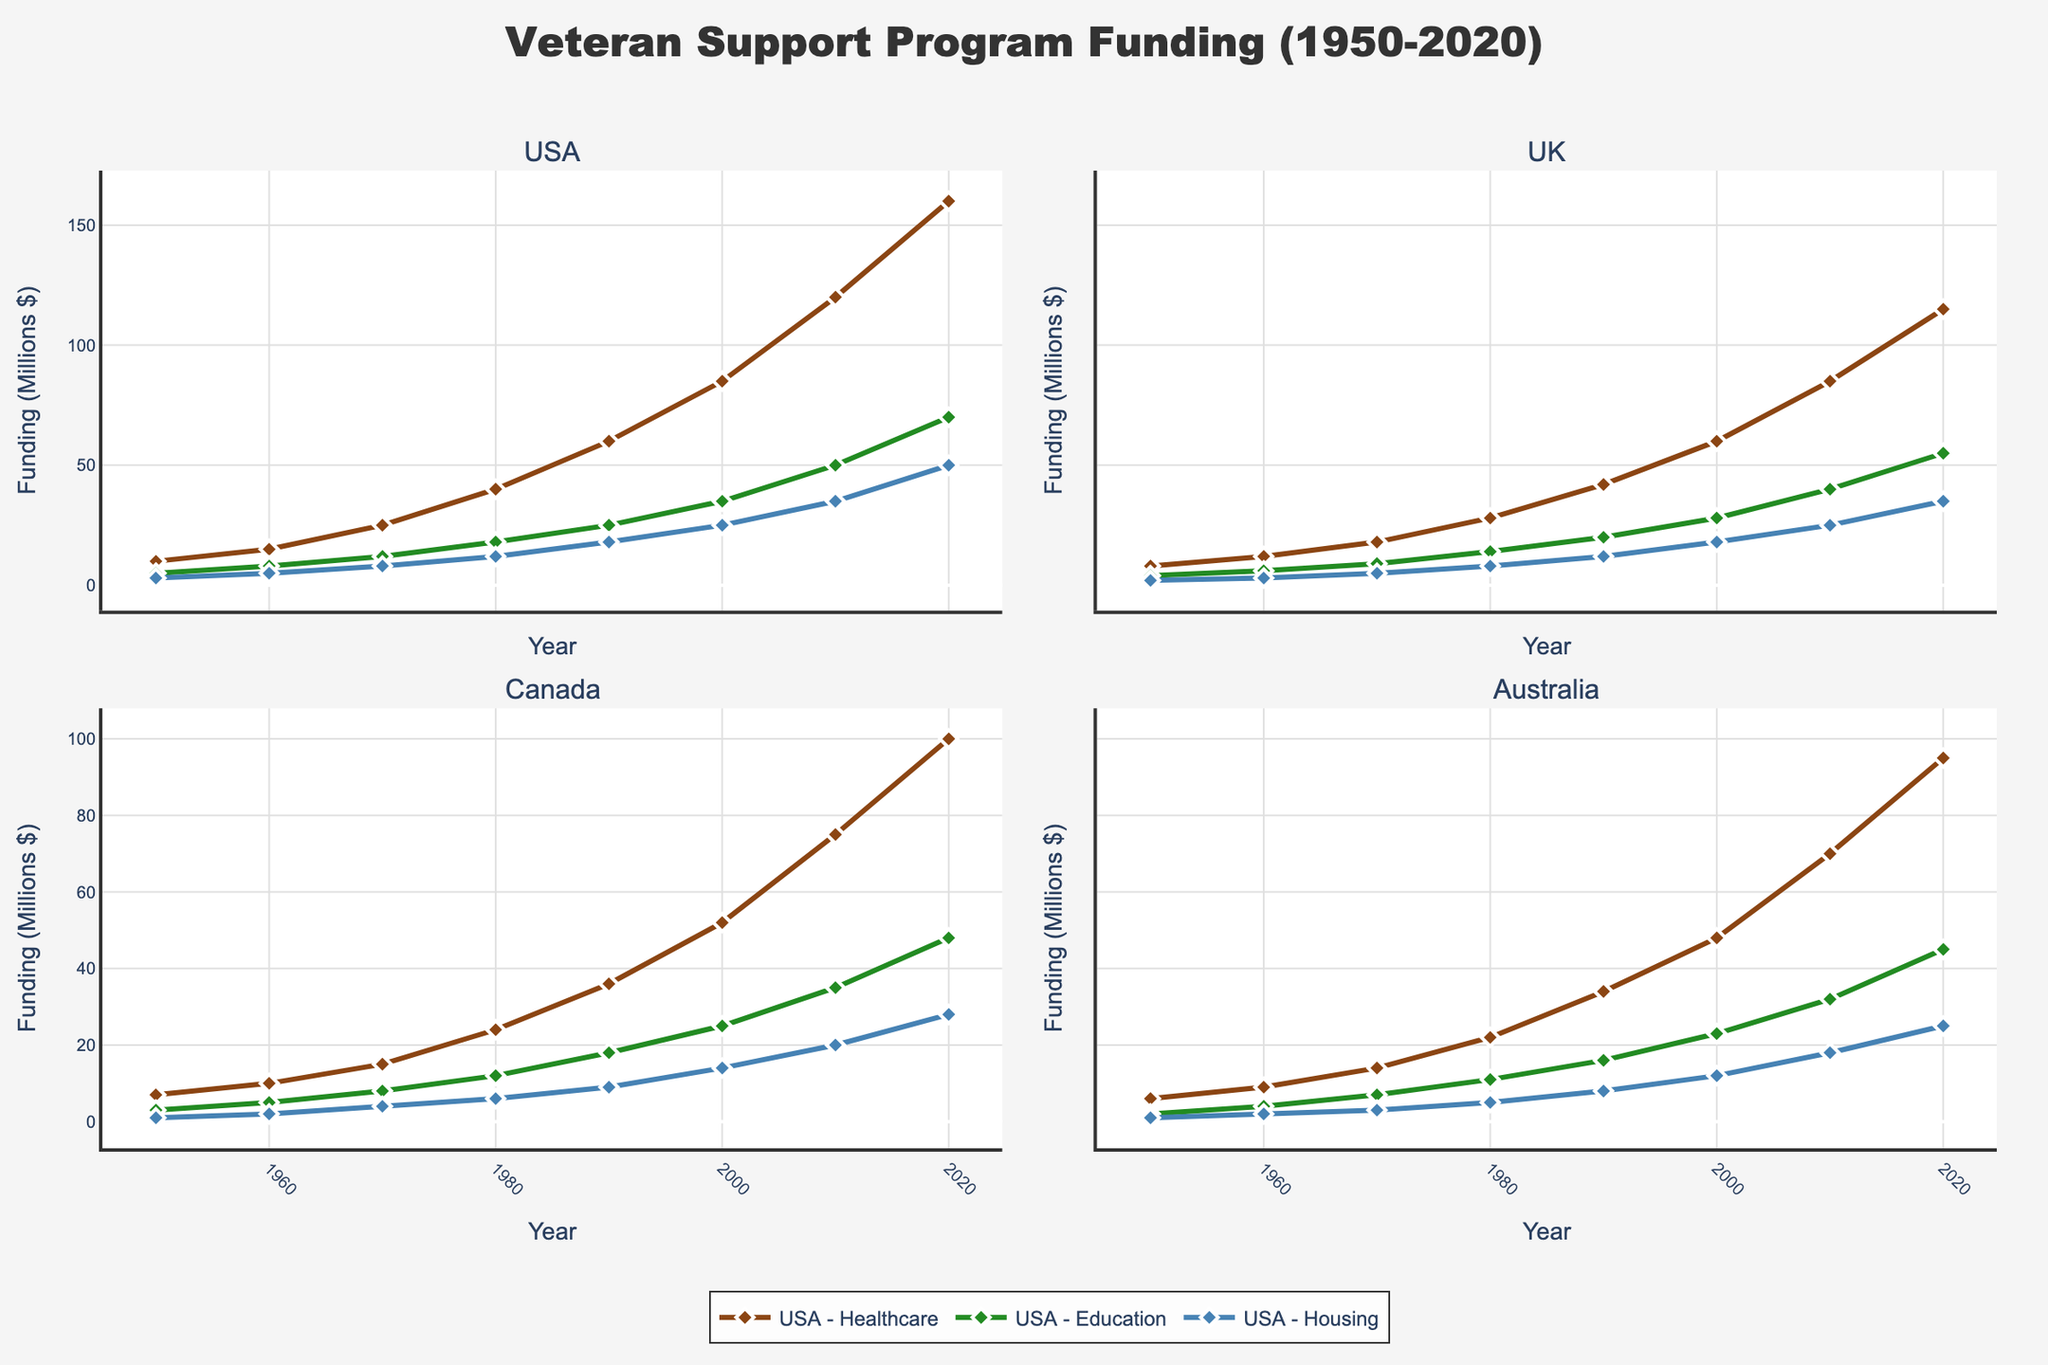Which country had the highest healthcare funding in 2020? We need to identify the healthcare funding values for the year 2020 across all countries and then see which one is the highest. The values are: USA: 160, UK: 115, Canada: 100, Australia: 95. The highest value is 160 for the USA.
Answer: USA Which type of veteran support program received the most funding in Canada in 1970? Looking at the plot for Canada in 1970, we need to compare the values for healthcare, education, and housing. The values are: Healthcare: 15, Education: 8, Housing: 4. The highest value is 15 for healthcare.
Answer: Healthcare How much did the USA's education funding increase from 2000 to 2010? We find the values for USA's education funding in 2000 and 2010, which are 35 and 50 respectively. The increase is calculated by subtracting the 2000 value from the 2010 value: 50 - 35 = 15.
Answer: 15 What is the combined healthcare funding for the UK and Australia in 1980? We need to add the healthcare funding values for the UK and Australia in 1980. The values are: UK: 28, Australia: 22. The combined funding is 28 + 22 = 50.
Answer: 50 Which country had the lowest housing funding in 1950? We need to identify the housing funding values for the year 1950 across all countries and see which one is the lowest. The values are: USA: 3, UK: 2, Canada: 1, Australia: 1. The lowest value is 1, shared by both Canada and Australia.
Answer: Canada and Australia How did the UK’s healthcare funding in 1960 compare to its education funding in the same year? We look at the values for the UK's healthcare and education funding in 1960, which are 12 and 6 respectively. Healthcare funding is twice the education funding.
Answer: Healthcare funding is twice education funding Among the countries, which had the highest increase in housing funding from 1990 to 2020? We need to find the housing funding values for 1990 and 2020 for all countries and calculate the increase (2020 value - 1990 value). Then we see which increase is the highest. The increases are: USA: 50 - 18 = 32, UK: 35 - 12 = 23, Canada: 28 - 9 = 19, Australia: 25 - 8 = 17. The highest increase is 32 for the USA.
Answer: USA Which funding type saw the largest increase in the UK from 1950 to 2020? We compare the increases in each funding type in the UK from 1950 to 2020. The values are: Healthcare: 115 - 8 = 107, Education: 55 - 4 = 51, Housing: 35 - 2 = 33. The largest increase is in healthcare.
Answer: Healthcare What is the average healthcare funding for Australia from 1950 to 2020? Summing the healthcare values for Australia from 1950 to 2020 and dividing by the number of data points. The values to sum are: 6, 9, 14, 22, 34, 48, 70, 95. The sum is 298, and since there are 8 data points, the average is 298 / 8 = 37.25.
Answer: 37.25 